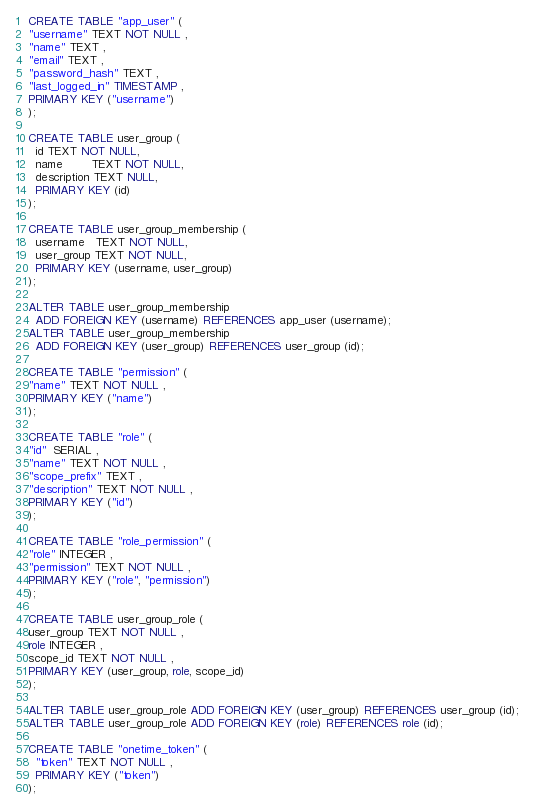<code> <loc_0><loc_0><loc_500><loc_500><_SQL_>CREATE TABLE "app_user" (
"username" TEXT NOT NULL ,
"name" TEXT ,
"email" TEXT ,
"password_hash" TEXT ,
"last_logged_in" TIMESTAMP ,
PRIMARY KEY ("username")
);

CREATE TABLE user_group (
  id TEXT NOT NULL,
  name        TEXT NOT NULL,
  description TEXT NULL,
  PRIMARY KEY (id)
);

CREATE TABLE user_group_membership (
  username   TEXT NOT NULL,
  user_group TEXT NOT NULL,
  PRIMARY KEY (username, user_group)
);

ALTER TABLE user_group_membership
  ADD FOREIGN KEY (username) REFERENCES app_user (username);
ALTER TABLE user_group_membership
  ADD FOREIGN KEY (user_group) REFERENCES user_group (id);

CREATE TABLE "permission" (
"name" TEXT NOT NULL ,
PRIMARY KEY ("name")
);

CREATE TABLE "role" (
"id"  SERIAL ,
"name" TEXT NOT NULL ,
"scope_prefix" TEXT ,
"description" TEXT NOT NULL ,
PRIMARY KEY ("id")
);

CREATE TABLE "role_permission" (
"role" INTEGER ,
"permission" TEXT NOT NULL ,
PRIMARY KEY ("role", "permission")
);

CREATE TABLE user_group_role (
user_group TEXT NOT NULL ,
role INTEGER ,
scope_id TEXT NOT NULL ,
PRIMARY KEY (user_group, role, scope_id)
);

ALTER TABLE user_group_role ADD FOREIGN KEY (user_group) REFERENCES user_group (id);
ALTER TABLE user_group_role ADD FOREIGN KEY (role) REFERENCES role (id);

CREATE TABLE "onetime_token" (
  "token" TEXT NOT NULL ,
  PRIMARY KEY ("token")
);
</code> 